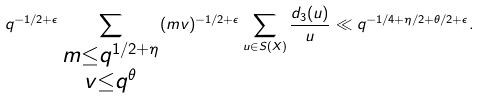Convert formula to latex. <formula><loc_0><loc_0><loc_500><loc_500>q ^ { - 1 / 2 + \epsilon } \sum _ { \substack { m \leq q ^ { 1 / 2 + \eta } \\ v \leq q ^ { \theta } } } ( m v ) ^ { - 1 / 2 + \epsilon } \sum _ { u \in S ( X ) } \frac { d _ { 3 } ( u ) } { u } \ll q ^ { - 1 / 4 + \eta / 2 + \theta / 2 + \epsilon } .</formula> 